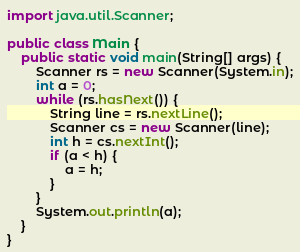Convert code to text. <code><loc_0><loc_0><loc_500><loc_500><_Java_>
import java.util.Scanner;

public class Main {
	public static void main(String[] args) {
		Scanner rs = new Scanner(System.in);
		int a = 0;
		while (rs.hasNext()) {
			String line = rs.nextLine();
			Scanner cs = new Scanner(line);
			int h = cs.nextInt();
			if (a < h) {
				a = h;
			}
		}
		System.out.println(a);
	}
}</code> 